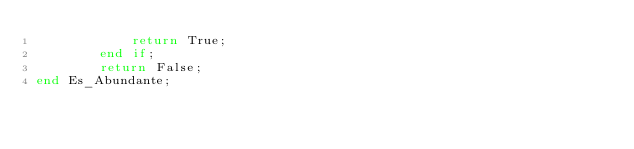Convert code to text. <code><loc_0><loc_0><loc_500><loc_500><_Ada_>            return True;
        end if;
        return False; 
end Es_Abundante;</code> 